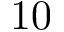Convert formula to latex. <formula><loc_0><loc_0><loc_500><loc_500>1 0</formula> 